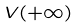<formula> <loc_0><loc_0><loc_500><loc_500>V ( + \infty )</formula> 